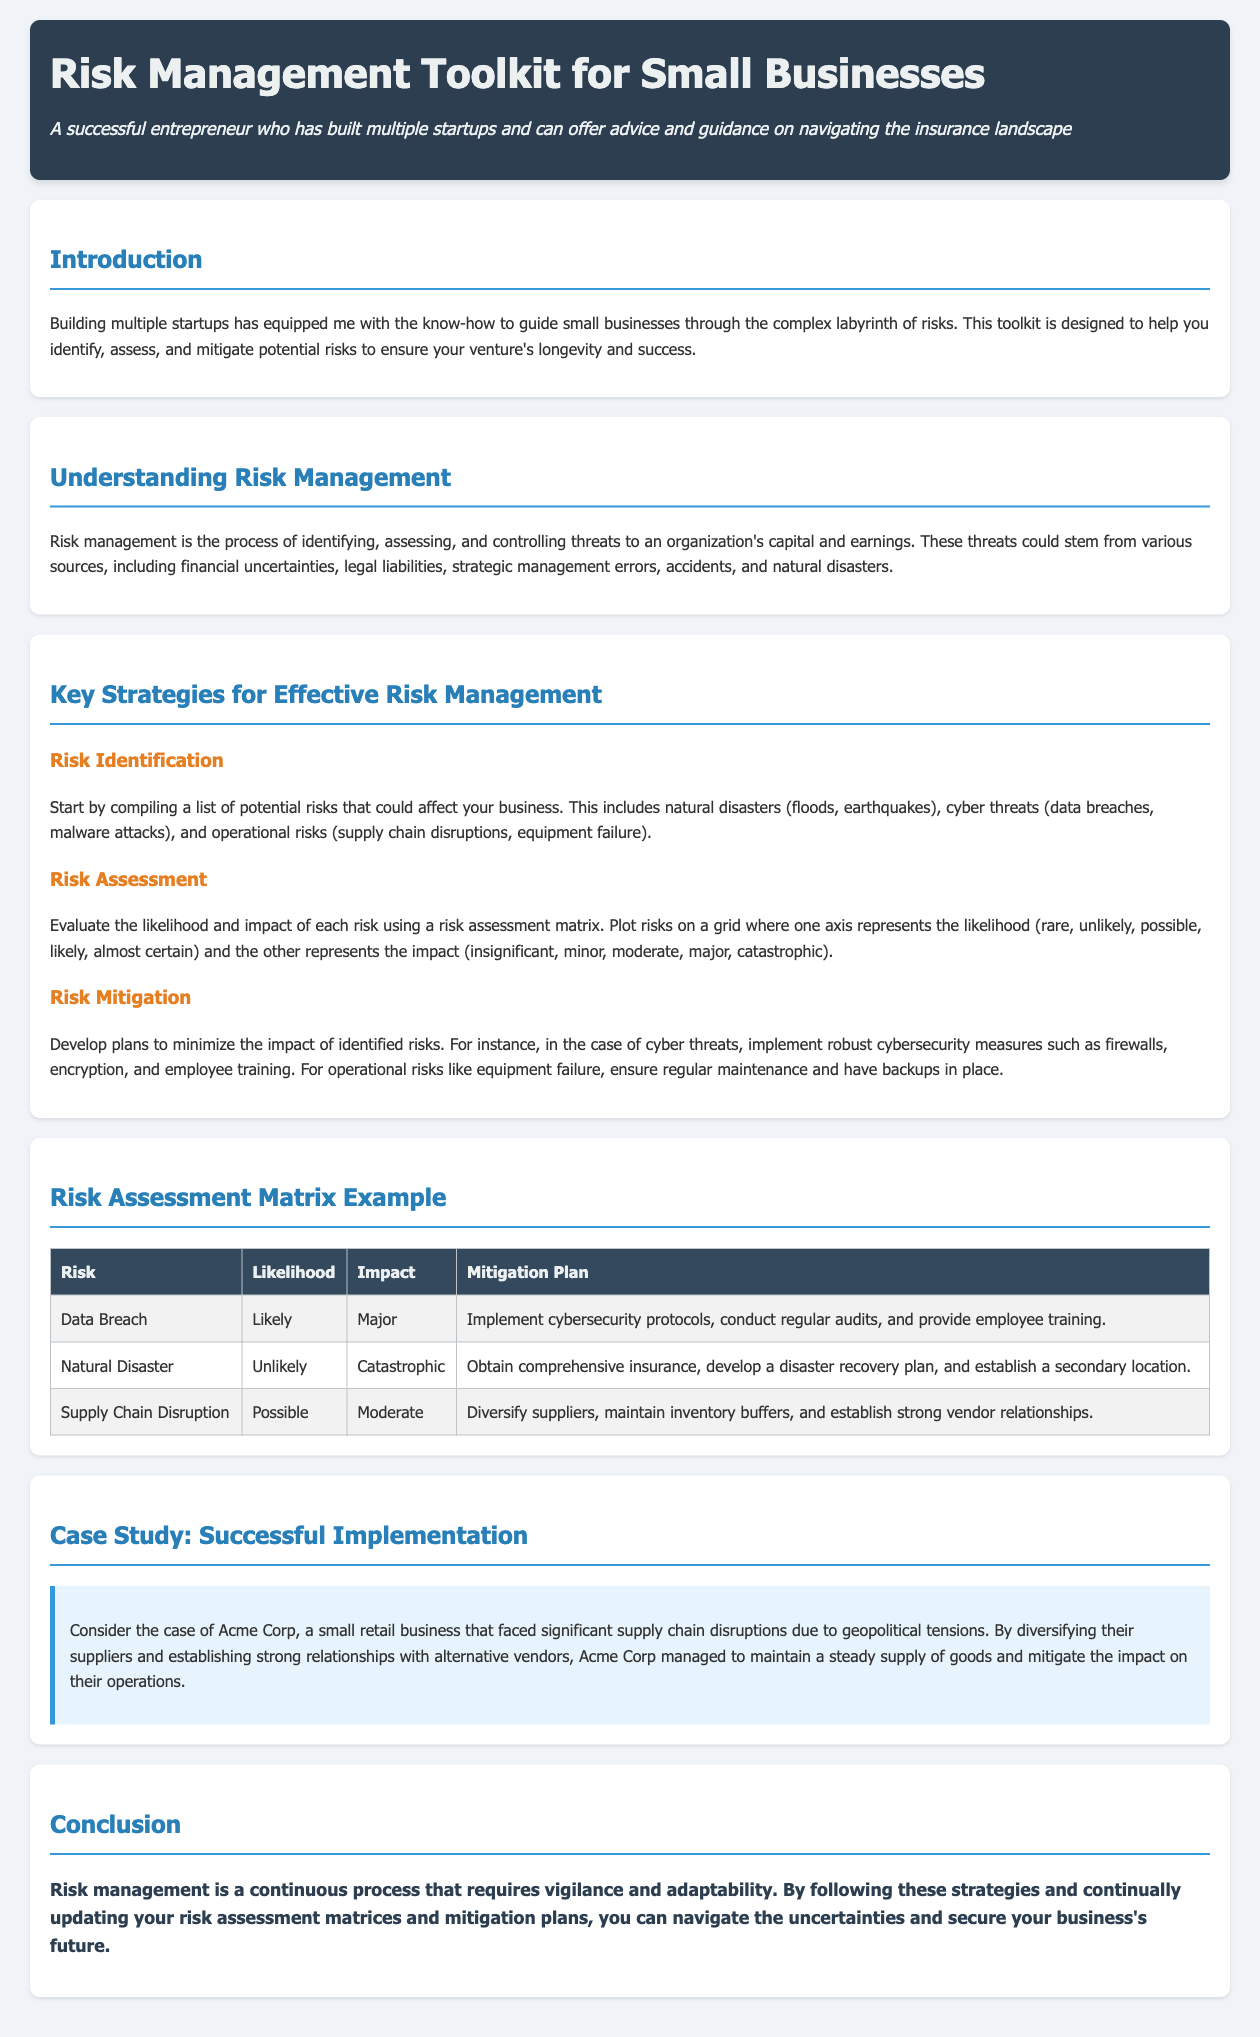What is the title of the document? The title of the document is the main heading at the top, which indicates the purpose of the toolkit for small businesses.
Answer: Risk Management Toolkit for Small Businesses What kind of risks should small businesses identify? The document provides examples of risks that businesses should consider, including natural disasters, cyber threats, and operational risks.
Answer: Natural disasters, cyber threats, operational risks What is the likelihood of a data breach? The likelihood category for the data breach risk is classified in the risk assessment matrix presented in the document.
Answer: Likely What is the impact level of a natural disaster according to the matrix? The document lists the impact to identify how severe it would be in the context of risk management.
Answer: Catastrophic Who is mentioned in the case study? The case study highlights a fictional business to illustrate the principles discussed in the document for real-world application.
Answer: Acme Corp Which strategy involves creating plans to minimize risk impact? The document categorizes the process of reducing potential losses under a specific strategy relating to managing identified risks.
Answer: Risk Mitigation What type of matrix is used for risk assessment? The document describes a specific type of tool used to evaluate and visualize risks based on likelihood and impact.
Answer: Risk assessment matrix How should supply chain disruptions be handled? The document outlines specific actions to address supply chain issues in the context of risk management.
Answer: Diversify suppliers, maintain inventory buffers What is the conclusion about risk management? The conclusion summarizes the essential idea presented in the toolkit regarding the nature of risk management for ongoing business strategy.
Answer: Continuous process requiring vigilance and adaptability 